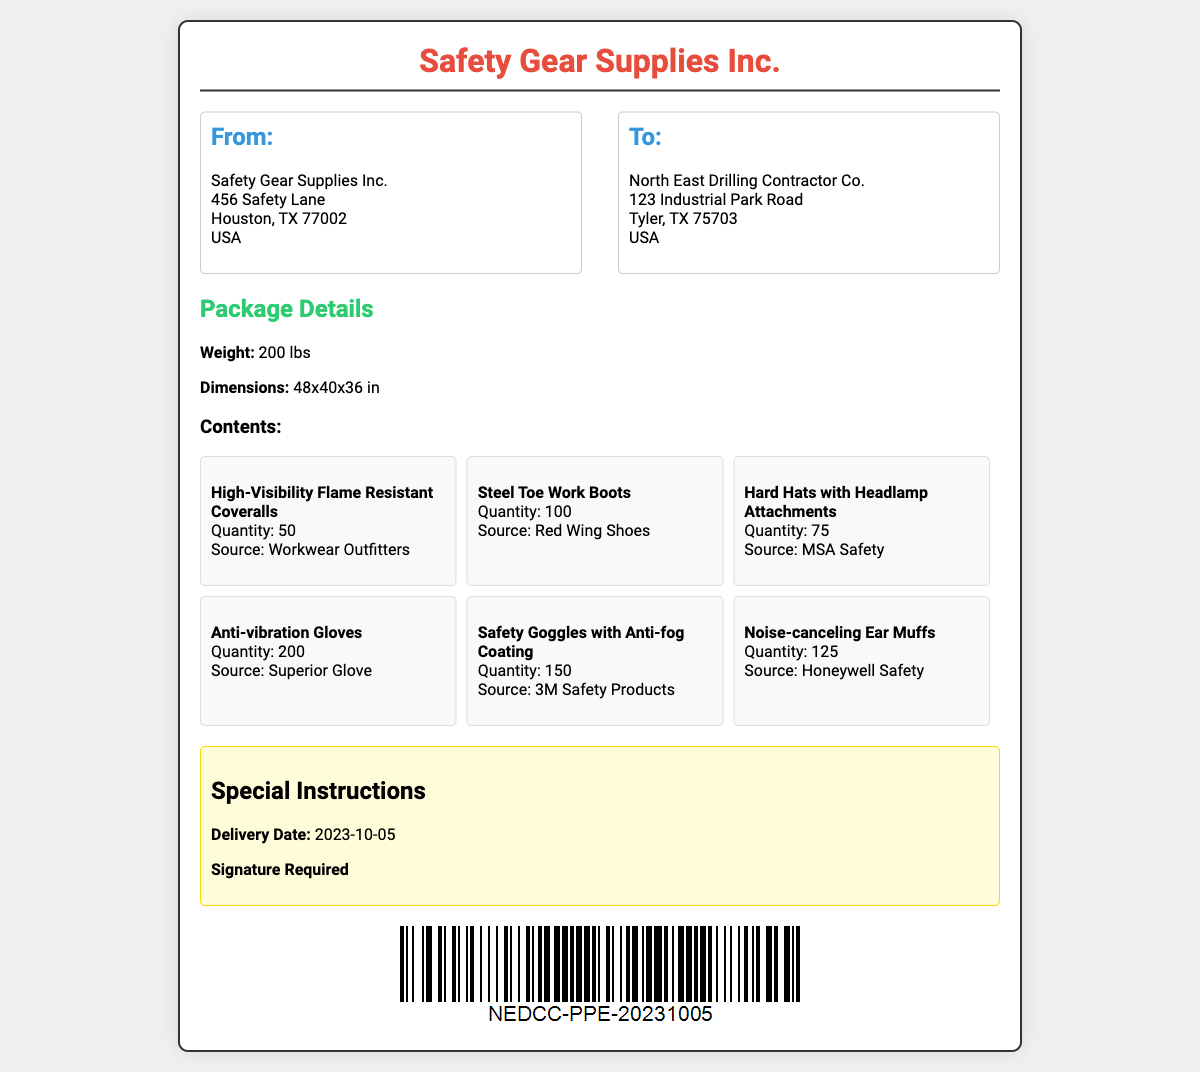What is the sender's address? The sender's address is listed under "From:" in the document, which includes the company name, street address, city, state, and ZIP code.
Answer: Safety Gear Supplies Inc., 456 Safety Lane, Houston, TX 77002, USA What is the delivery date? The delivery date is mentioned in the "Special Instructions" section of the document.
Answer: 2023-10-05 How many high-visibility coveralls were shipped? The number of high-visibility flame resistant coveralls can be found in the "Contents" section of the document, specifically for that item.
Answer: 50 What is the weight of the package? The weight of the package is stated in the "Package Details" section of the document.
Answer: 200 lbs Which company provided the steel toe work boots? The source of the steel toe work boots is specified in the "Contents" section alongside the item description.
Answer: Red Wing Shoes What is the total number of items being shipped? To find the total number of items, add the quantities listed for each type of equipment in the "Contents".
Answer: 625 What type of safety gear is included for noise protection? The type of safety gear for noise protection is mentioned in the item descriptions in the "Contents".
Answer: Noise-canceling Ear Muffs How many safety goggles are included in the shipment? The quantity of safety goggles can be found in the "Contents" section under the corresponding item description.
Answer: 150 